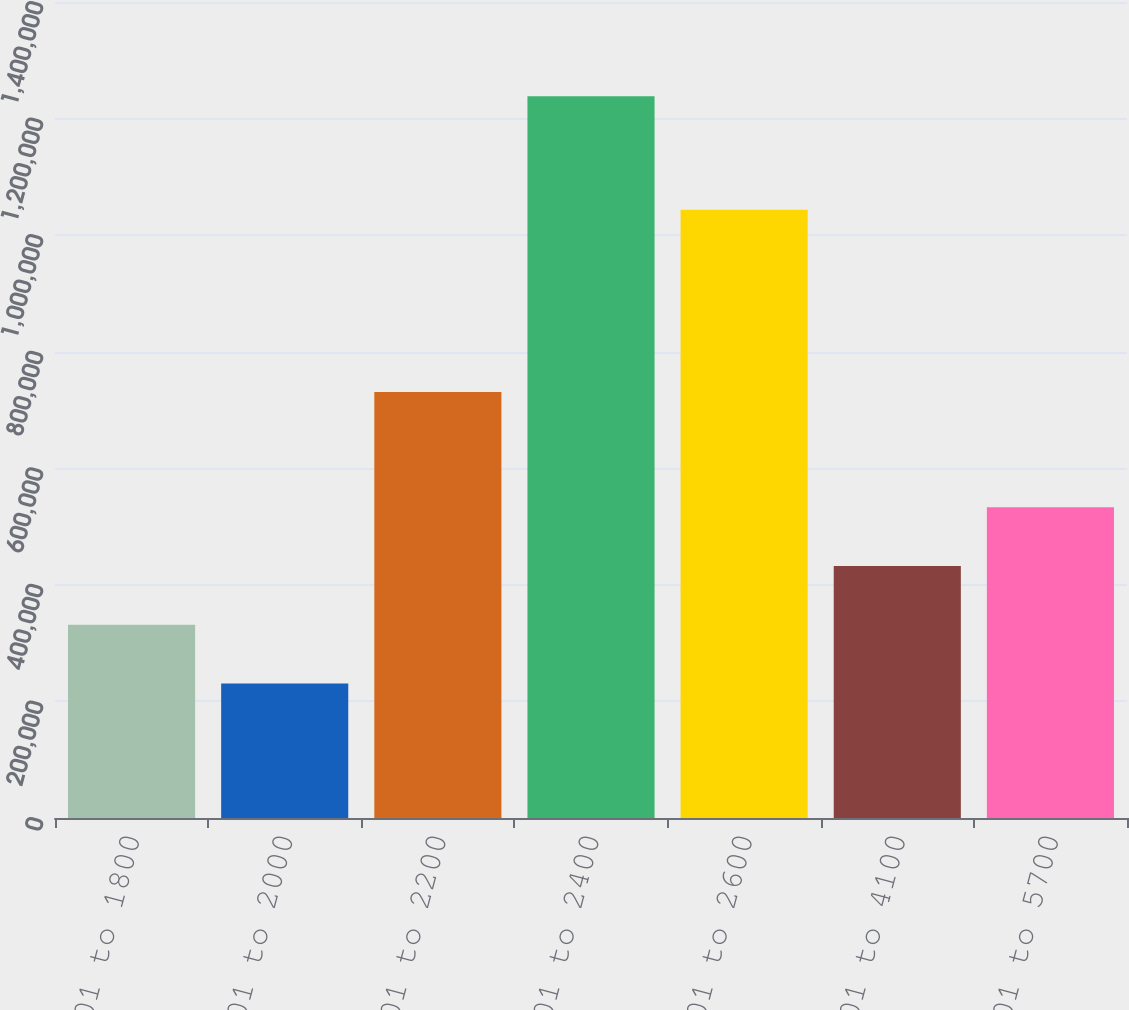Convert chart. <chart><loc_0><loc_0><loc_500><loc_500><bar_chart><fcel>001 to 1800<fcel>1801 to 2000<fcel>2001 to 2200<fcel>2201 to 2400<fcel>2401 to 2600<fcel>2601 to 4100<fcel>4101 to 5700<nl><fcel>331602<fcel>230862<fcel>730702<fcel>1.23826e+06<fcel>1.04335e+06<fcel>432342<fcel>533083<nl></chart> 